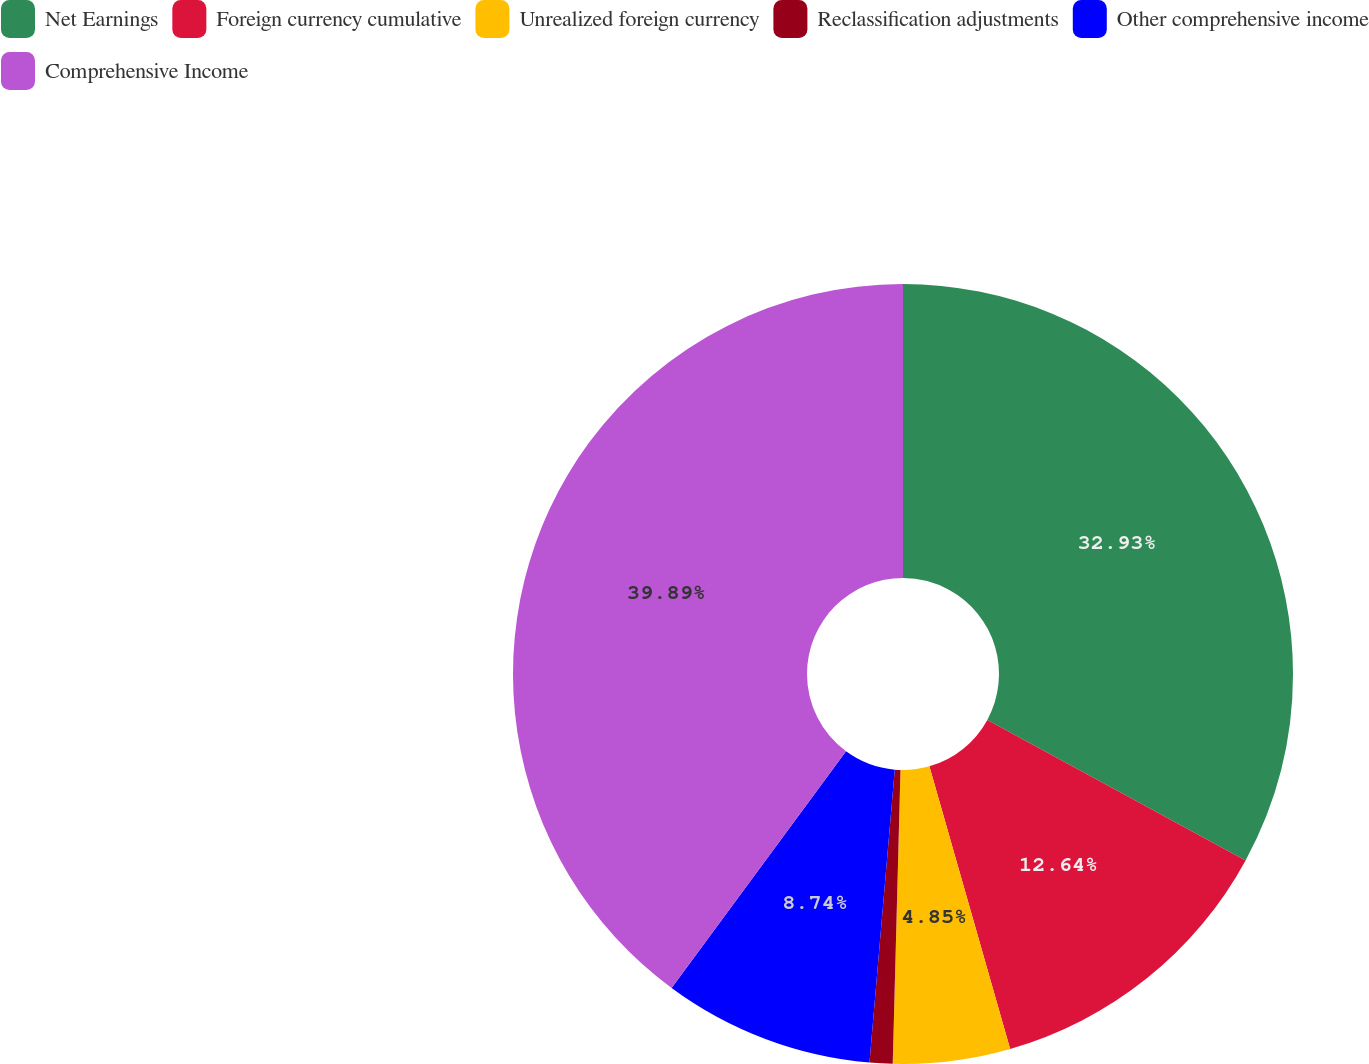Convert chart. <chart><loc_0><loc_0><loc_500><loc_500><pie_chart><fcel>Net Earnings<fcel>Foreign currency cumulative<fcel>Unrealized foreign currency<fcel>Reclassification adjustments<fcel>Other comprehensive income<fcel>Comprehensive Income<nl><fcel>32.93%<fcel>12.64%<fcel>4.85%<fcel>0.95%<fcel>8.74%<fcel>39.89%<nl></chart> 